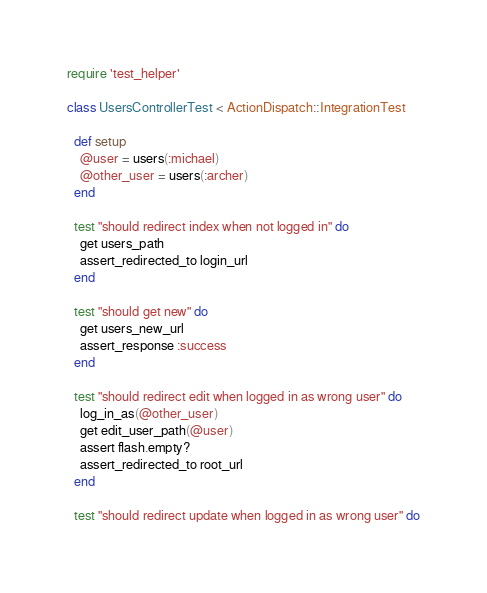Convert code to text. <code><loc_0><loc_0><loc_500><loc_500><_Ruby_>require 'test_helper'

class UsersControllerTest < ActionDispatch::IntegrationTest
  
  def setup
    @user = users(:michael)
    @other_user = users(:archer)
  end
  
  test "should redirect index when not logged in" do
    get users_path
    assert_redirected_to login_url
  end
  
  test "should get new" do
    get users_new_url
    assert_response :success
  end

  test "should redirect edit when logged in as wrong user" do
    log_in_as(@other_user)
    get edit_user_path(@user)
    assert flash.empty?
    assert_redirected_to root_url
  end
  
  test "should redirect update when logged in as wrong user" do</code> 